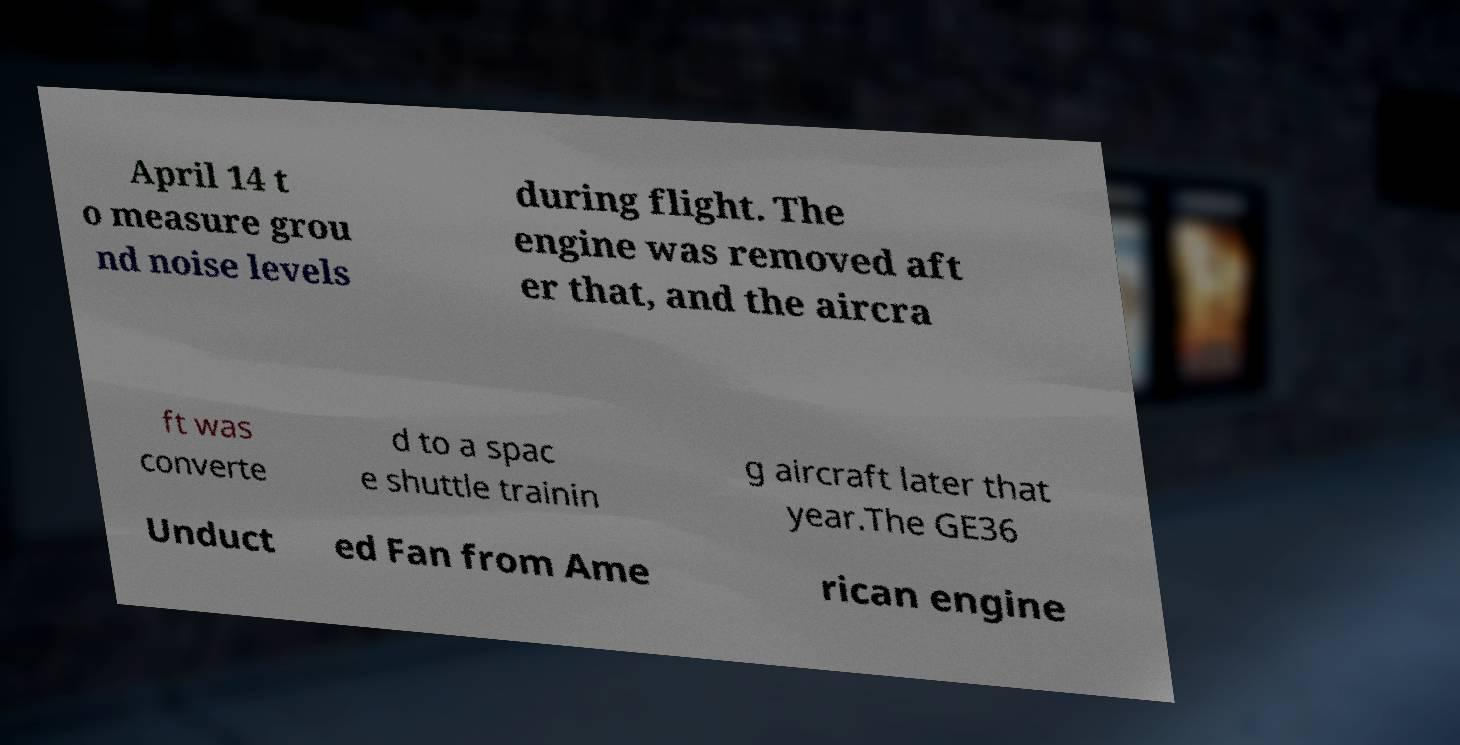Could you extract and type out the text from this image? April 14 t o measure grou nd noise levels during flight. The engine was removed aft er that, and the aircra ft was converte d to a spac e shuttle trainin g aircraft later that year.The GE36 Unduct ed Fan from Ame rican engine 